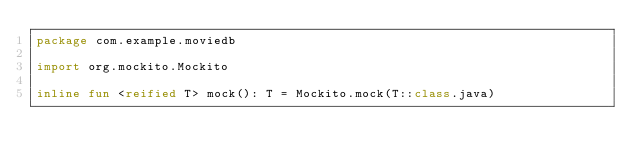<code> <loc_0><loc_0><loc_500><loc_500><_Kotlin_>package com.example.moviedb

import org.mockito.Mockito

inline fun <reified T> mock(): T = Mockito.mock(T::class.java)</code> 